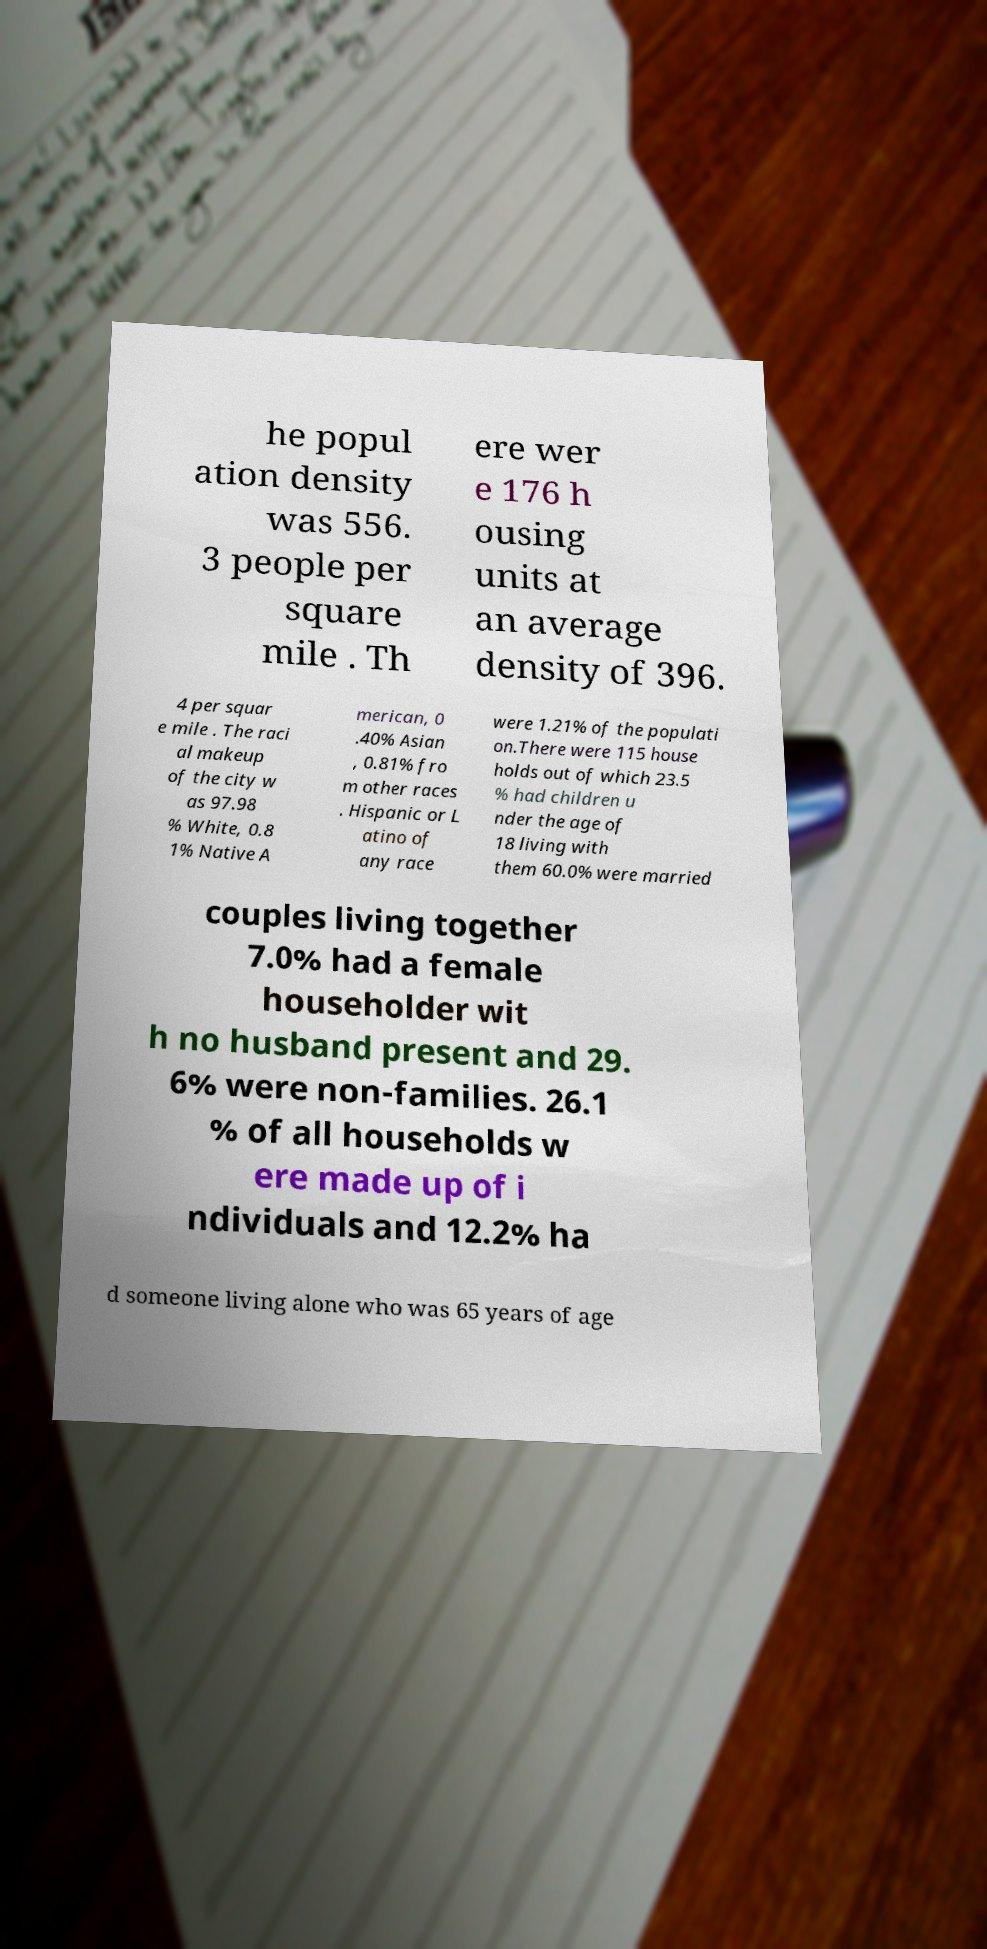Could you extract and type out the text from this image? he popul ation density was 556. 3 people per square mile . Th ere wer e 176 h ousing units at an average density of 396. 4 per squar e mile . The raci al makeup of the city w as 97.98 % White, 0.8 1% Native A merican, 0 .40% Asian , 0.81% fro m other races . Hispanic or L atino of any race were 1.21% of the populati on.There were 115 house holds out of which 23.5 % had children u nder the age of 18 living with them 60.0% were married couples living together 7.0% had a female householder wit h no husband present and 29. 6% were non-families. 26.1 % of all households w ere made up of i ndividuals and 12.2% ha d someone living alone who was 65 years of age 